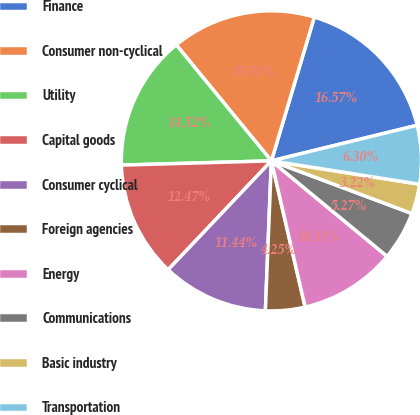<chart> <loc_0><loc_0><loc_500><loc_500><pie_chart><fcel>Finance<fcel>Consumer non-cyclical<fcel>Utility<fcel>Capital goods<fcel>Consumer cyclical<fcel>Foreign agencies<fcel>Energy<fcel>Communications<fcel>Basic industry<fcel>Transportation<nl><fcel>16.57%<fcel>15.55%<fcel>14.52%<fcel>12.47%<fcel>11.44%<fcel>4.25%<fcel>10.41%<fcel>5.27%<fcel>3.22%<fcel>6.3%<nl></chart> 